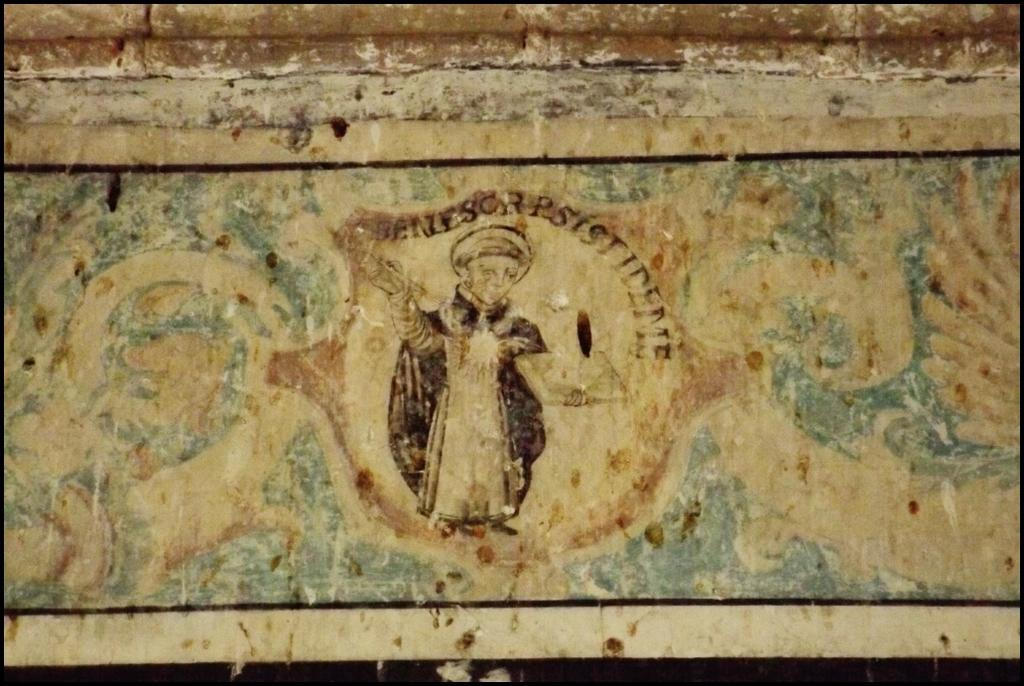What type of structure is in the image? There is an old structure in the image. What colors can be seen on the structure? The structure is cream, black, and brown in color. Is there any artwork on the structure? Yes, there is a painting of a person on the structure, which is of a person. What type of books can be found in the library depicted in the image? There is no library present in the image; it features an old structure with a painting of a person. 